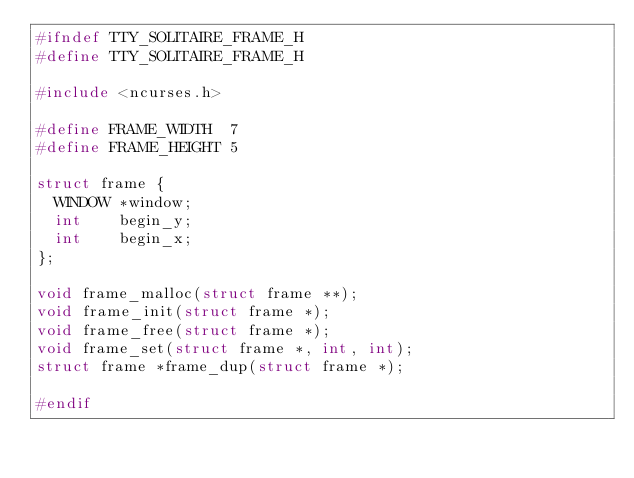<code> <loc_0><loc_0><loc_500><loc_500><_C_>#ifndef TTY_SOLITAIRE_FRAME_H
#define TTY_SOLITAIRE_FRAME_H

#include <ncurses.h>

#define FRAME_WIDTH  7
#define FRAME_HEIGHT 5

struct frame {
  WINDOW *window;
  int    begin_y;
  int    begin_x;
};

void frame_malloc(struct frame **);
void frame_init(struct frame *);
void frame_free(struct frame *);
void frame_set(struct frame *, int, int);
struct frame *frame_dup(struct frame *);

#endif
</code> 